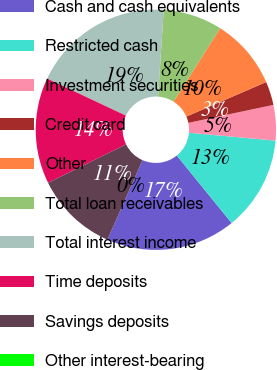Convert chart. <chart><loc_0><loc_0><loc_500><loc_500><pie_chart><fcel>Cash and cash equivalents<fcel>Restricted cash<fcel>Investment securities<fcel>Credit card<fcel>Other<fcel>Total loan receivables<fcel>Total interest income<fcel>Time deposits<fcel>Savings deposits<fcel>Other interest-bearing<nl><fcel>17.46%<fcel>12.7%<fcel>4.76%<fcel>3.18%<fcel>9.52%<fcel>7.94%<fcel>19.04%<fcel>14.28%<fcel>11.11%<fcel>0.0%<nl></chart> 